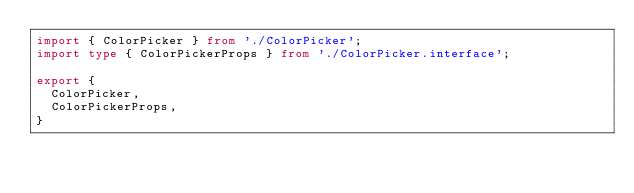Convert code to text. <code><loc_0><loc_0><loc_500><loc_500><_TypeScript_>import { ColorPicker } from './ColorPicker';
import type { ColorPickerProps } from './ColorPicker.interface';

export {
  ColorPicker,
  ColorPickerProps,
}
</code> 